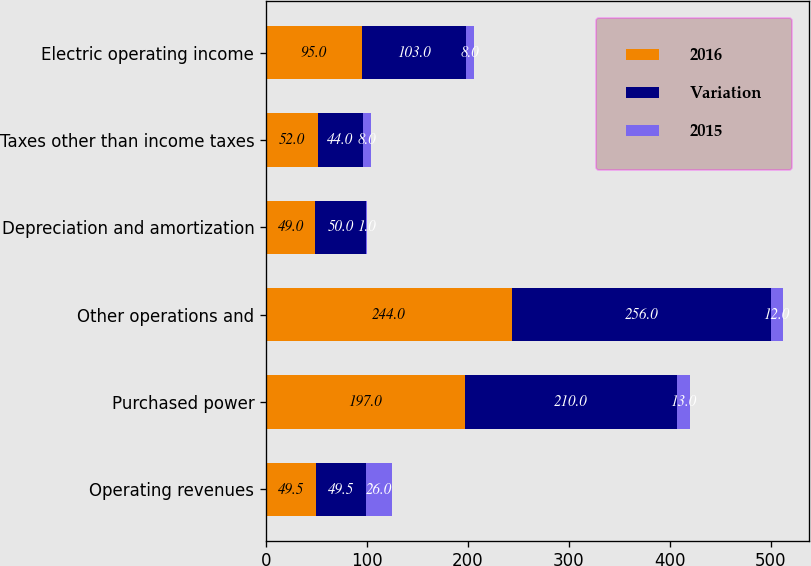Convert chart. <chart><loc_0><loc_0><loc_500><loc_500><stacked_bar_chart><ecel><fcel>Operating revenues<fcel>Purchased power<fcel>Other operations and<fcel>Depreciation and amortization<fcel>Taxes other than income taxes<fcel>Electric operating income<nl><fcel>2016<fcel>49.5<fcel>197<fcel>244<fcel>49<fcel>52<fcel>95<nl><fcel>Variation<fcel>49.5<fcel>210<fcel>256<fcel>50<fcel>44<fcel>103<nl><fcel>2015<fcel>26<fcel>13<fcel>12<fcel>1<fcel>8<fcel>8<nl></chart> 